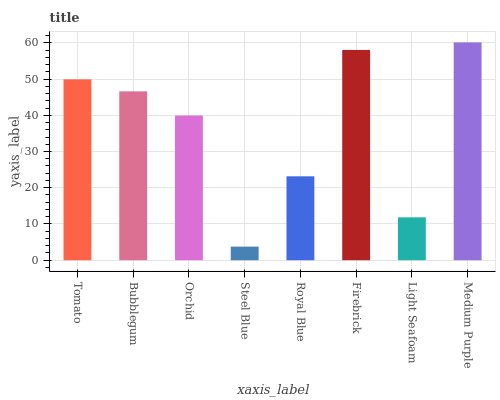Is Steel Blue the minimum?
Answer yes or no. Yes. Is Medium Purple the maximum?
Answer yes or no. Yes. Is Bubblegum the minimum?
Answer yes or no. No. Is Bubblegum the maximum?
Answer yes or no. No. Is Tomato greater than Bubblegum?
Answer yes or no. Yes. Is Bubblegum less than Tomato?
Answer yes or no. Yes. Is Bubblegum greater than Tomato?
Answer yes or no. No. Is Tomato less than Bubblegum?
Answer yes or no. No. Is Bubblegum the high median?
Answer yes or no. Yes. Is Orchid the low median?
Answer yes or no. Yes. Is Royal Blue the high median?
Answer yes or no. No. Is Medium Purple the low median?
Answer yes or no. No. 